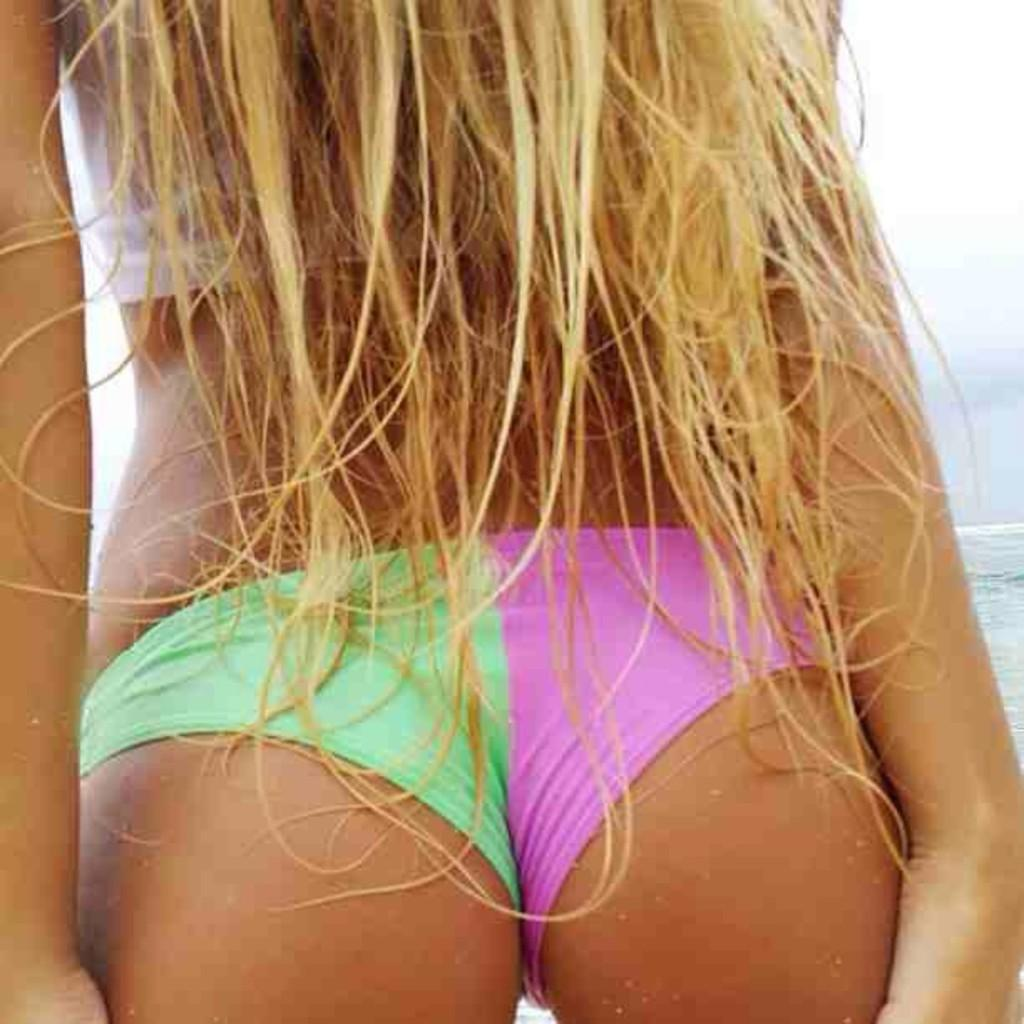Who is present in the image? There is a woman in the image. What can be seen in the image besides the woman? Water is visible in the image. What is visible in the background of the image? The sky is visible in the background of the image. What type of linen is being used to make the pie in the image? There is no pie or linen present in the image. 